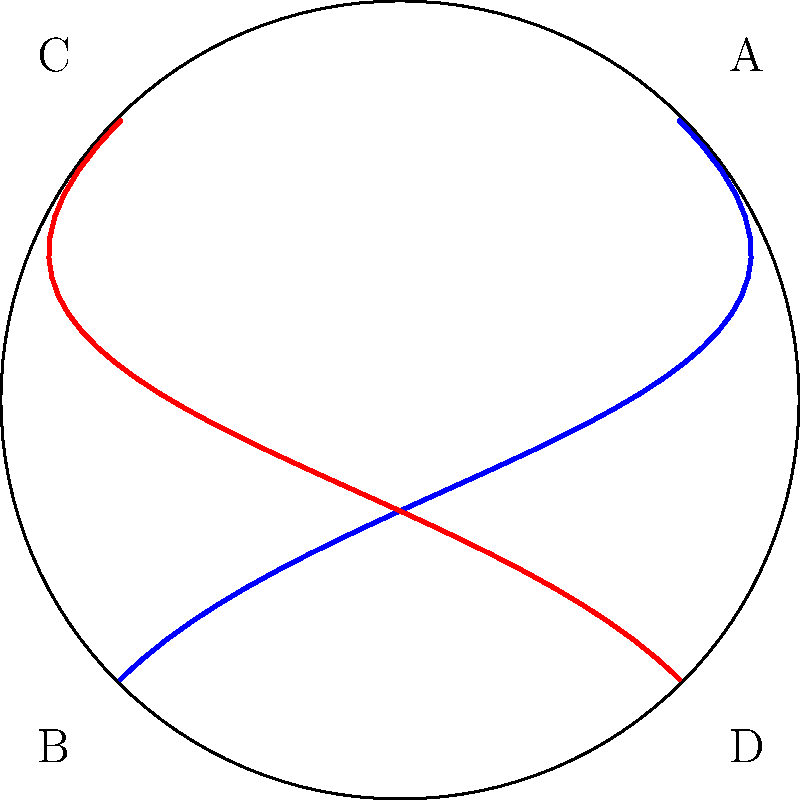On a sci-fi movie set, you're asked to explain the concept of curved space to your fellow actors. The set designer has created a spherical backdrop to represent a planet's surface. If you were to draw two "straight" lines between opposite points on this sphere (A to B and C to D), as shown in the diagram, how would these lines appear, and what does this demonstrate about Non-Euclidean geometry? To understand this concept, let's break it down step-by-step:

1. In Euclidean geometry (flat space), the shortest distance between two points is a straight line.

2. However, on a curved surface like a sphere, which represents Non-Euclidean geometry, the concept of a "straight" line changes.

3. On a sphere, the shortest path between two points is called a geodesic, which appears as a curved line when projected onto a flat surface.

4. In the diagram, the blue and red curves represent these geodesics between points A-B and C-D, respectively.

5. These curves are actually great circles on the sphere, which are the equivalent of "straight" lines in spherical geometry.

6. Notice that these two "straight" lines (geodesics) intersect at two points, unlike parallel lines in Euclidean geometry which never intersect.

7. This intersection demonstrates a key property of spherical geometry: on a sphere, there are no truly parallel lines.

8. The curvature of these lines also illustrates how the shortest path on a curved surface is not a Euclidean straight line.

9. In the context of general relativity, this curved space concept is used to explain how massive objects bend spacetime, affecting the paths of light and objects.

This visualization helps to demonstrate that in Non-Euclidean geometries, such as on curved surfaces, our intuitive understanding of straight lines and parallel lines from flat (Euclidean) geometry no longer applies.
Answer: The lines appear curved, demonstrating that in Non-Euclidean (spherical) geometry, "straight" lines are geodesics that can intersect, and parallel lines don't exist. 